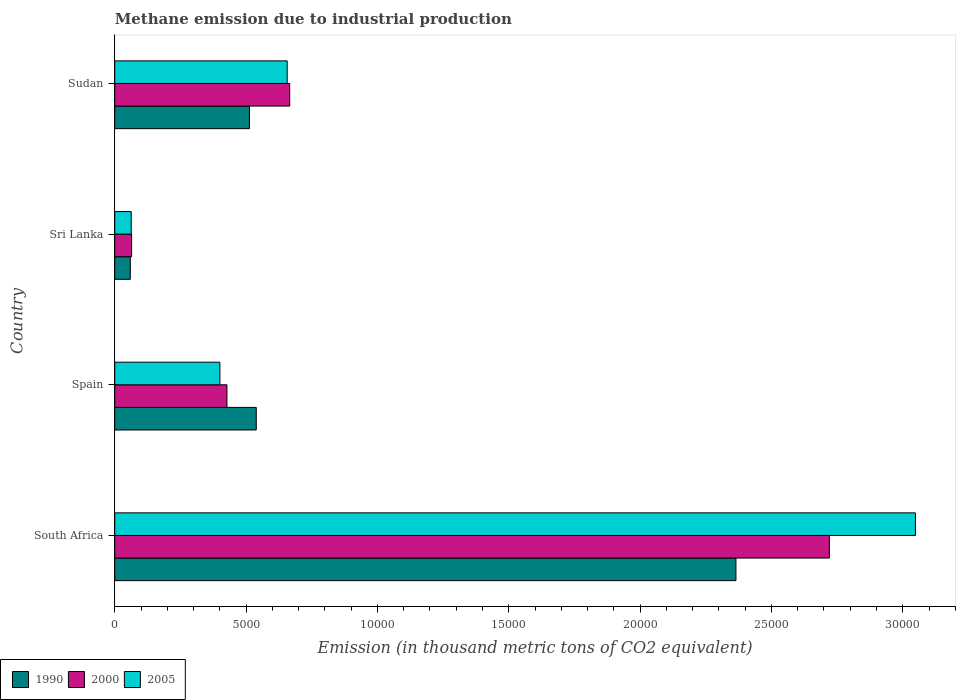How many bars are there on the 1st tick from the top?
Offer a very short reply. 3. What is the label of the 2nd group of bars from the top?
Your response must be concise. Sri Lanka. In how many cases, is the number of bars for a given country not equal to the number of legend labels?
Your response must be concise. 0. What is the amount of methane emitted in 1990 in South Africa?
Your answer should be very brief. 2.36e+04. Across all countries, what is the maximum amount of methane emitted in 1990?
Provide a short and direct response. 2.36e+04. Across all countries, what is the minimum amount of methane emitted in 2000?
Ensure brevity in your answer.  642.2. In which country was the amount of methane emitted in 2000 maximum?
Your answer should be compact. South Africa. In which country was the amount of methane emitted in 1990 minimum?
Your answer should be very brief. Sri Lanka. What is the total amount of methane emitted in 2000 in the graph?
Your answer should be compact. 3.88e+04. What is the difference between the amount of methane emitted in 2000 in Sri Lanka and that in Sudan?
Offer a terse response. -6018.7. What is the difference between the amount of methane emitted in 2000 in Spain and the amount of methane emitted in 1990 in Sudan?
Offer a very short reply. -858.1. What is the average amount of methane emitted in 2005 per country?
Keep it short and to the point. 1.04e+04. What is the difference between the amount of methane emitted in 2000 and amount of methane emitted in 2005 in Sudan?
Your answer should be very brief. 95.8. What is the ratio of the amount of methane emitted in 2005 in Sri Lanka to that in Sudan?
Make the answer very short. 0.1. Is the amount of methane emitted in 2005 in Sri Lanka less than that in Sudan?
Keep it short and to the point. Yes. Is the difference between the amount of methane emitted in 2000 in South Africa and Spain greater than the difference between the amount of methane emitted in 2005 in South Africa and Spain?
Offer a very short reply. No. What is the difference between the highest and the second highest amount of methane emitted in 2005?
Your response must be concise. 2.39e+04. What is the difference between the highest and the lowest amount of methane emitted in 1990?
Provide a short and direct response. 2.31e+04. Is the sum of the amount of methane emitted in 2000 in Spain and Sri Lanka greater than the maximum amount of methane emitted in 2005 across all countries?
Your answer should be compact. No. What does the 1st bar from the bottom in Sri Lanka represents?
Offer a terse response. 1990. Is it the case that in every country, the sum of the amount of methane emitted in 2005 and amount of methane emitted in 1990 is greater than the amount of methane emitted in 2000?
Make the answer very short. Yes. How many countries are there in the graph?
Your answer should be very brief. 4. What is the difference between two consecutive major ticks on the X-axis?
Ensure brevity in your answer.  5000. Does the graph contain grids?
Your answer should be very brief. No. Where does the legend appear in the graph?
Make the answer very short. Bottom left. What is the title of the graph?
Make the answer very short. Methane emission due to industrial production. What is the label or title of the X-axis?
Give a very brief answer. Emission (in thousand metric tons of CO2 equivalent). What is the label or title of the Y-axis?
Provide a short and direct response. Country. What is the Emission (in thousand metric tons of CO2 equivalent) of 1990 in South Africa?
Keep it short and to the point. 2.36e+04. What is the Emission (in thousand metric tons of CO2 equivalent) of 2000 in South Africa?
Your answer should be compact. 2.72e+04. What is the Emission (in thousand metric tons of CO2 equivalent) of 2005 in South Africa?
Provide a short and direct response. 3.05e+04. What is the Emission (in thousand metric tons of CO2 equivalent) of 1990 in Spain?
Your response must be concise. 5387.8. What is the Emission (in thousand metric tons of CO2 equivalent) of 2000 in Spain?
Your response must be concise. 4271. What is the Emission (in thousand metric tons of CO2 equivalent) in 2005 in Spain?
Provide a short and direct response. 4002.6. What is the Emission (in thousand metric tons of CO2 equivalent) of 1990 in Sri Lanka?
Make the answer very short. 591.8. What is the Emission (in thousand metric tons of CO2 equivalent) in 2000 in Sri Lanka?
Your answer should be very brief. 642.2. What is the Emission (in thousand metric tons of CO2 equivalent) in 2005 in Sri Lanka?
Your response must be concise. 627.3. What is the Emission (in thousand metric tons of CO2 equivalent) in 1990 in Sudan?
Keep it short and to the point. 5129.1. What is the Emission (in thousand metric tons of CO2 equivalent) in 2000 in Sudan?
Your answer should be compact. 6660.9. What is the Emission (in thousand metric tons of CO2 equivalent) of 2005 in Sudan?
Offer a terse response. 6565.1. Across all countries, what is the maximum Emission (in thousand metric tons of CO2 equivalent) in 1990?
Ensure brevity in your answer.  2.36e+04. Across all countries, what is the maximum Emission (in thousand metric tons of CO2 equivalent) in 2000?
Your answer should be very brief. 2.72e+04. Across all countries, what is the maximum Emission (in thousand metric tons of CO2 equivalent) in 2005?
Ensure brevity in your answer.  3.05e+04. Across all countries, what is the minimum Emission (in thousand metric tons of CO2 equivalent) of 1990?
Provide a short and direct response. 591.8. Across all countries, what is the minimum Emission (in thousand metric tons of CO2 equivalent) of 2000?
Your response must be concise. 642.2. Across all countries, what is the minimum Emission (in thousand metric tons of CO2 equivalent) in 2005?
Give a very brief answer. 627.3. What is the total Emission (in thousand metric tons of CO2 equivalent) in 1990 in the graph?
Offer a terse response. 3.48e+04. What is the total Emission (in thousand metric tons of CO2 equivalent) in 2000 in the graph?
Give a very brief answer. 3.88e+04. What is the total Emission (in thousand metric tons of CO2 equivalent) in 2005 in the graph?
Provide a succinct answer. 4.17e+04. What is the difference between the Emission (in thousand metric tons of CO2 equivalent) in 1990 in South Africa and that in Spain?
Your answer should be very brief. 1.83e+04. What is the difference between the Emission (in thousand metric tons of CO2 equivalent) in 2000 in South Africa and that in Spain?
Your response must be concise. 2.29e+04. What is the difference between the Emission (in thousand metric tons of CO2 equivalent) in 2005 in South Africa and that in Spain?
Your response must be concise. 2.65e+04. What is the difference between the Emission (in thousand metric tons of CO2 equivalent) of 1990 in South Africa and that in Sri Lanka?
Give a very brief answer. 2.31e+04. What is the difference between the Emission (in thousand metric tons of CO2 equivalent) of 2000 in South Africa and that in Sri Lanka?
Offer a very short reply. 2.66e+04. What is the difference between the Emission (in thousand metric tons of CO2 equivalent) in 2005 in South Africa and that in Sri Lanka?
Provide a short and direct response. 2.99e+04. What is the difference between the Emission (in thousand metric tons of CO2 equivalent) in 1990 in South Africa and that in Sudan?
Offer a very short reply. 1.85e+04. What is the difference between the Emission (in thousand metric tons of CO2 equivalent) in 2000 in South Africa and that in Sudan?
Provide a succinct answer. 2.05e+04. What is the difference between the Emission (in thousand metric tons of CO2 equivalent) of 2005 in South Africa and that in Sudan?
Offer a very short reply. 2.39e+04. What is the difference between the Emission (in thousand metric tons of CO2 equivalent) of 1990 in Spain and that in Sri Lanka?
Ensure brevity in your answer.  4796. What is the difference between the Emission (in thousand metric tons of CO2 equivalent) of 2000 in Spain and that in Sri Lanka?
Ensure brevity in your answer.  3628.8. What is the difference between the Emission (in thousand metric tons of CO2 equivalent) in 2005 in Spain and that in Sri Lanka?
Your answer should be very brief. 3375.3. What is the difference between the Emission (in thousand metric tons of CO2 equivalent) in 1990 in Spain and that in Sudan?
Give a very brief answer. 258.7. What is the difference between the Emission (in thousand metric tons of CO2 equivalent) of 2000 in Spain and that in Sudan?
Your answer should be compact. -2389.9. What is the difference between the Emission (in thousand metric tons of CO2 equivalent) in 2005 in Spain and that in Sudan?
Offer a terse response. -2562.5. What is the difference between the Emission (in thousand metric tons of CO2 equivalent) in 1990 in Sri Lanka and that in Sudan?
Ensure brevity in your answer.  -4537.3. What is the difference between the Emission (in thousand metric tons of CO2 equivalent) of 2000 in Sri Lanka and that in Sudan?
Your answer should be compact. -6018.7. What is the difference between the Emission (in thousand metric tons of CO2 equivalent) of 2005 in Sri Lanka and that in Sudan?
Keep it short and to the point. -5937.8. What is the difference between the Emission (in thousand metric tons of CO2 equivalent) in 1990 in South Africa and the Emission (in thousand metric tons of CO2 equivalent) in 2000 in Spain?
Your answer should be very brief. 1.94e+04. What is the difference between the Emission (in thousand metric tons of CO2 equivalent) in 1990 in South Africa and the Emission (in thousand metric tons of CO2 equivalent) in 2005 in Spain?
Your response must be concise. 1.96e+04. What is the difference between the Emission (in thousand metric tons of CO2 equivalent) of 2000 in South Africa and the Emission (in thousand metric tons of CO2 equivalent) of 2005 in Spain?
Your response must be concise. 2.32e+04. What is the difference between the Emission (in thousand metric tons of CO2 equivalent) of 1990 in South Africa and the Emission (in thousand metric tons of CO2 equivalent) of 2000 in Sri Lanka?
Make the answer very short. 2.30e+04. What is the difference between the Emission (in thousand metric tons of CO2 equivalent) of 1990 in South Africa and the Emission (in thousand metric tons of CO2 equivalent) of 2005 in Sri Lanka?
Offer a terse response. 2.30e+04. What is the difference between the Emission (in thousand metric tons of CO2 equivalent) of 2000 in South Africa and the Emission (in thousand metric tons of CO2 equivalent) of 2005 in Sri Lanka?
Your answer should be compact. 2.66e+04. What is the difference between the Emission (in thousand metric tons of CO2 equivalent) in 1990 in South Africa and the Emission (in thousand metric tons of CO2 equivalent) in 2000 in Sudan?
Your response must be concise. 1.70e+04. What is the difference between the Emission (in thousand metric tons of CO2 equivalent) of 1990 in South Africa and the Emission (in thousand metric tons of CO2 equivalent) of 2005 in Sudan?
Ensure brevity in your answer.  1.71e+04. What is the difference between the Emission (in thousand metric tons of CO2 equivalent) in 2000 in South Africa and the Emission (in thousand metric tons of CO2 equivalent) in 2005 in Sudan?
Your response must be concise. 2.06e+04. What is the difference between the Emission (in thousand metric tons of CO2 equivalent) of 1990 in Spain and the Emission (in thousand metric tons of CO2 equivalent) of 2000 in Sri Lanka?
Provide a succinct answer. 4745.6. What is the difference between the Emission (in thousand metric tons of CO2 equivalent) in 1990 in Spain and the Emission (in thousand metric tons of CO2 equivalent) in 2005 in Sri Lanka?
Your answer should be compact. 4760.5. What is the difference between the Emission (in thousand metric tons of CO2 equivalent) in 2000 in Spain and the Emission (in thousand metric tons of CO2 equivalent) in 2005 in Sri Lanka?
Your response must be concise. 3643.7. What is the difference between the Emission (in thousand metric tons of CO2 equivalent) of 1990 in Spain and the Emission (in thousand metric tons of CO2 equivalent) of 2000 in Sudan?
Your answer should be compact. -1273.1. What is the difference between the Emission (in thousand metric tons of CO2 equivalent) in 1990 in Spain and the Emission (in thousand metric tons of CO2 equivalent) in 2005 in Sudan?
Give a very brief answer. -1177.3. What is the difference between the Emission (in thousand metric tons of CO2 equivalent) in 2000 in Spain and the Emission (in thousand metric tons of CO2 equivalent) in 2005 in Sudan?
Give a very brief answer. -2294.1. What is the difference between the Emission (in thousand metric tons of CO2 equivalent) in 1990 in Sri Lanka and the Emission (in thousand metric tons of CO2 equivalent) in 2000 in Sudan?
Keep it short and to the point. -6069.1. What is the difference between the Emission (in thousand metric tons of CO2 equivalent) in 1990 in Sri Lanka and the Emission (in thousand metric tons of CO2 equivalent) in 2005 in Sudan?
Make the answer very short. -5973.3. What is the difference between the Emission (in thousand metric tons of CO2 equivalent) in 2000 in Sri Lanka and the Emission (in thousand metric tons of CO2 equivalent) in 2005 in Sudan?
Offer a very short reply. -5922.9. What is the average Emission (in thousand metric tons of CO2 equivalent) of 1990 per country?
Keep it short and to the point. 8689.55. What is the average Emission (in thousand metric tons of CO2 equivalent) of 2000 per country?
Ensure brevity in your answer.  9695.48. What is the average Emission (in thousand metric tons of CO2 equivalent) of 2005 per country?
Offer a very short reply. 1.04e+04. What is the difference between the Emission (in thousand metric tons of CO2 equivalent) in 1990 and Emission (in thousand metric tons of CO2 equivalent) in 2000 in South Africa?
Give a very brief answer. -3558.3. What is the difference between the Emission (in thousand metric tons of CO2 equivalent) of 1990 and Emission (in thousand metric tons of CO2 equivalent) of 2005 in South Africa?
Your answer should be compact. -6834.8. What is the difference between the Emission (in thousand metric tons of CO2 equivalent) of 2000 and Emission (in thousand metric tons of CO2 equivalent) of 2005 in South Africa?
Ensure brevity in your answer.  -3276.5. What is the difference between the Emission (in thousand metric tons of CO2 equivalent) in 1990 and Emission (in thousand metric tons of CO2 equivalent) in 2000 in Spain?
Give a very brief answer. 1116.8. What is the difference between the Emission (in thousand metric tons of CO2 equivalent) of 1990 and Emission (in thousand metric tons of CO2 equivalent) of 2005 in Spain?
Give a very brief answer. 1385.2. What is the difference between the Emission (in thousand metric tons of CO2 equivalent) in 2000 and Emission (in thousand metric tons of CO2 equivalent) in 2005 in Spain?
Ensure brevity in your answer.  268.4. What is the difference between the Emission (in thousand metric tons of CO2 equivalent) in 1990 and Emission (in thousand metric tons of CO2 equivalent) in 2000 in Sri Lanka?
Provide a short and direct response. -50.4. What is the difference between the Emission (in thousand metric tons of CO2 equivalent) of 1990 and Emission (in thousand metric tons of CO2 equivalent) of 2005 in Sri Lanka?
Ensure brevity in your answer.  -35.5. What is the difference between the Emission (in thousand metric tons of CO2 equivalent) of 2000 and Emission (in thousand metric tons of CO2 equivalent) of 2005 in Sri Lanka?
Your response must be concise. 14.9. What is the difference between the Emission (in thousand metric tons of CO2 equivalent) of 1990 and Emission (in thousand metric tons of CO2 equivalent) of 2000 in Sudan?
Your response must be concise. -1531.8. What is the difference between the Emission (in thousand metric tons of CO2 equivalent) of 1990 and Emission (in thousand metric tons of CO2 equivalent) of 2005 in Sudan?
Your response must be concise. -1436. What is the difference between the Emission (in thousand metric tons of CO2 equivalent) of 2000 and Emission (in thousand metric tons of CO2 equivalent) of 2005 in Sudan?
Your answer should be compact. 95.8. What is the ratio of the Emission (in thousand metric tons of CO2 equivalent) of 1990 in South Africa to that in Spain?
Offer a terse response. 4.39. What is the ratio of the Emission (in thousand metric tons of CO2 equivalent) of 2000 in South Africa to that in Spain?
Ensure brevity in your answer.  6.37. What is the ratio of the Emission (in thousand metric tons of CO2 equivalent) in 2005 in South Africa to that in Spain?
Ensure brevity in your answer.  7.62. What is the ratio of the Emission (in thousand metric tons of CO2 equivalent) of 1990 in South Africa to that in Sri Lanka?
Provide a succinct answer. 39.96. What is the ratio of the Emission (in thousand metric tons of CO2 equivalent) in 2000 in South Africa to that in Sri Lanka?
Your answer should be very brief. 42.37. What is the ratio of the Emission (in thousand metric tons of CO2 equivalent) in 2005 in South Africa to that in Sri Lanka?
Your answer should be very brief. 48.6. What is the ratio of the Emission (in thousand metric tons of CO2 equivalent) of 1990 in South Africa to that in Sudan?
Provide a short and direct response. 4.61. What is the ratio of the Emission (in thousand metric tons of CO2 equivalent) in 2000 in South Africa to that in Sudan?
Offer a terse response. 4.08. What is the ratio of the Emission (in thousand metric tons of CO2 equivalent) of 2005 in South Africa to that in Sudan?
Give a very brief answer. 4.64. What is the ratio of the Emission (in thousand metric tons of CO2 equivalent) in 1990 in Spain to that in Sri Lanka?
Your answer should be compact. 9.1. What is the ratio of the Emission (in thousand metric tons of CO2 equivalent) in 2000 in Spain to that in Sri Lanka?
Keep it short and to the point. 6.65. What is the ratio of the Emission (in thousand metric tons of CO2 equivalent) of 2005 in Spain to that in Sri Lanka?
Your answer should be compact. 6.38. What is the ratio of the Emission (in thousand metric tons of CO2 equivalent) in 1990 in Spain to that in Sudan?
Ensure brevity in your answer.  1.05. What is the ratio of the Emission (in thousand metric tons of CO2 equivalent) in 2000 in Spain to that in Sudan?
Provide a succinct answer. 0.64. What is the ratio of the Emission (in thousand metric tons of CO2 equivalent) of 2005 in Spain to that in Sudan?
Your answer should be very brief. 0.61. What is the ratio of the Emission (in thousand metric tons of CO2 equivalent) of 1990 in Sri Lanka to that in Sudan?
Make the answer very short. 0.12. What is the ratio of the Emission (in thousand metric tons of CO2 equivalent) of 2000 in Sri Lanka to that in Sudan?
Make the answer very short. 0.1. What is the ratio of the Emission (in thousand metric tons of CO2 equivalent) in 2005 in Sri Lanka to that in Sudan?
Provide a short and direct response. 0.1. What is the difference between the highest and the second highest Emission (in thousand metric tons of CO2 equivalent) of 1990?
Make the answer very short. 1.83e+04. What is the difference between the highest and the second highest Emission (in thousand metric tons of CO2 equivalent) in 2000?
Give a very brief answer. 2.05e+04. What is the difference between the highest and the second highest Emission (in thousand metric tons of CO2 equivalent) of 2005?
Make the answer very short. 2.39e+04. What is the difference between the highest and the lowest Emission (in thousand metric tons of CO2 equivalent) in 1990?
Your response must be concise. 2.31e+04. What is the difference between the highest and the lowest Emission (in thousand metric tons of CO2 equivalent) of 2000?
Give a very brief answer. 2.66e+04. What is the difference between the highest and the lowest Emission (in thousand metric tons of CO2 equivalent) in 2005?
Ensure brevity in your answer.  2.99e+04. 